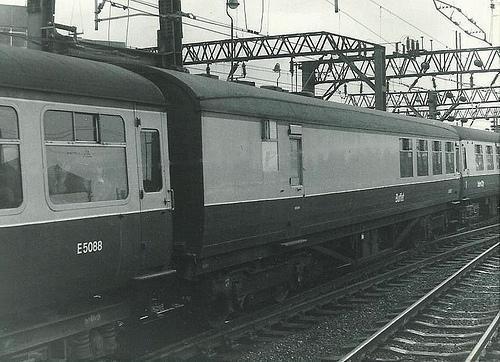How many trains are visible?
Give a very brief answer. 1. 